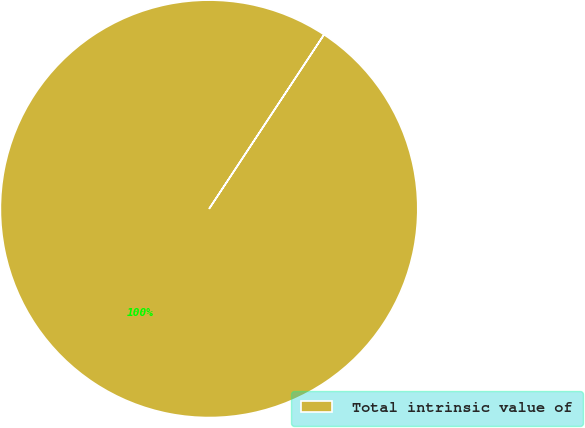Convert chart to OTSL. <chart><loc_0><loc_0><loc_500><loc_500><pie_chart><fcel>Total intrinsic value of<nl><fcel>100.0%<nl></chart> 